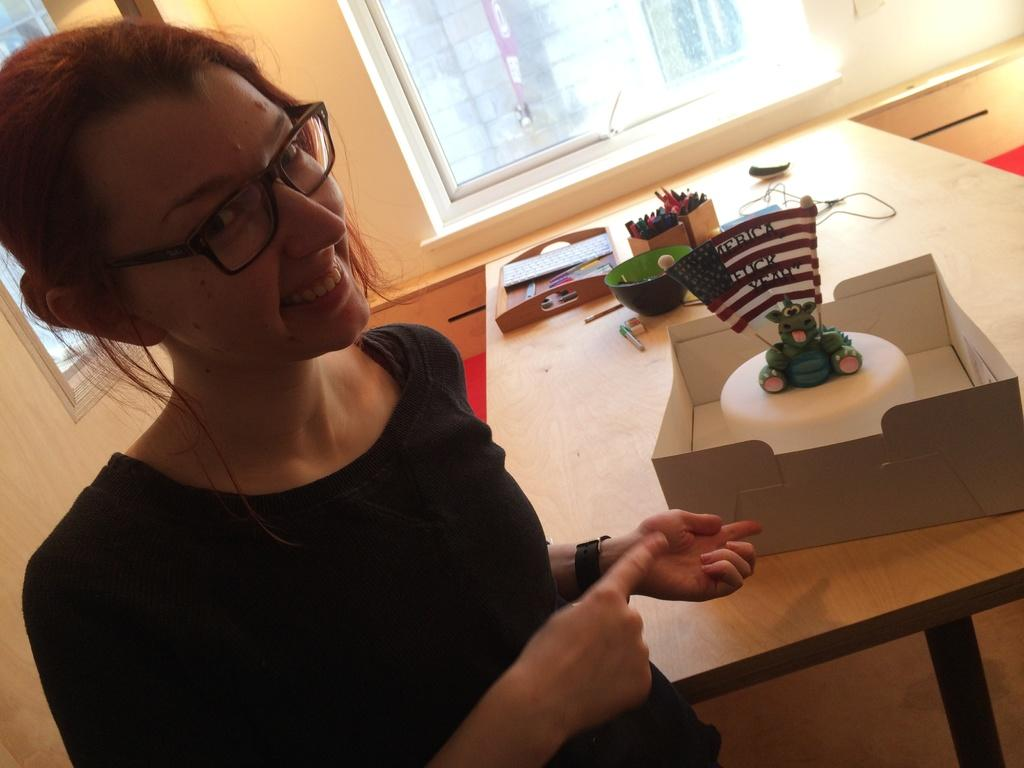Who is present in the image? There is a woman in the image. What is the woman doing in the image? The woman is smiling in the image. What is the woman wearing in the image? The woman is wearing a black dress in the image. What can be seen on the table in the image? There is a cake on the table in the image, along with other objects. What is visible through the window in the image? The facts provided do not mention anything visible through the window. What type of underwear is the woman wearing in the image? The facts provided do not mention any underwear, so it cannot be determined from the image. 